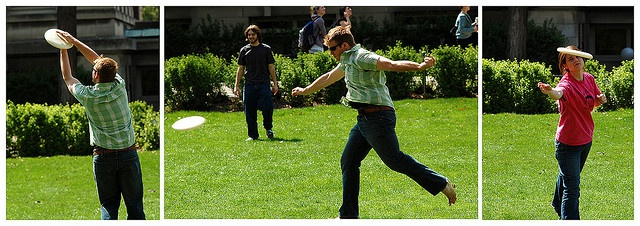Describe the objects in this image and their specific colors. I can see people in white, black, olive, and darkgreen tones, people in white, black, and darkgreen tones, people in white, black, maroon, brown, and olive tones, people in white, black, and olive tones, and people in white, black, gray, and maroon tones in this image. 